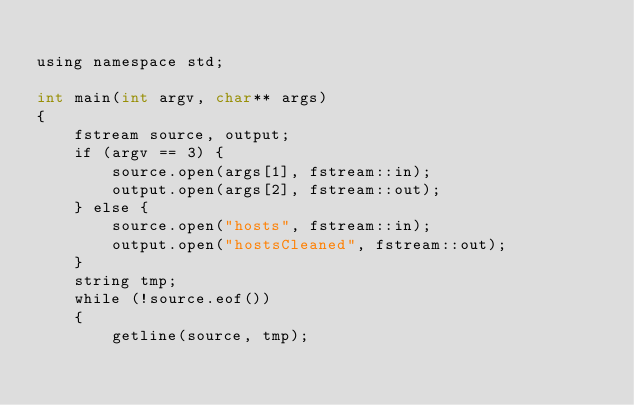<code> <loc_0><loc_0><loc_500><loc_500><_ObjectiveC_>
using namespace std;

int main(int argv, char** args)
{
	fstream source, output;
	if (argv == 3) {
		source.open(args[1], fstream::in);
		output.open(args[2], fstream::out);
	} else {
		source.open("hosts", fstream::in);
		output.open("hostsCleaned", fstream::out);
	}
	string tmp;
	while (!source.eof())
	{
		getline(source, tmp);</code> 